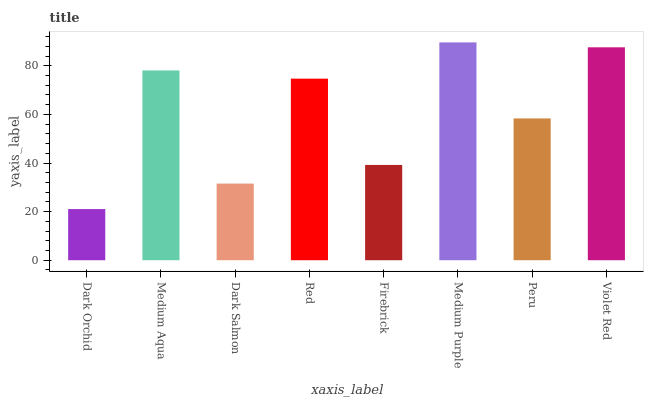Is Dark Orchid the minimum?
Answer yes or no. Yes. Is Medium Purple the maximum?
Answer yes or no. Yes. Is Medium Aqua the minimum?
Answer yes or no. No. Is Medium Aqua the maximum?
Answer yes or no. No. Is Medium Aqua greater than Dark Orchid?
Answer yes or no. Yes. Is Dark Orchid less than Medium Aqua?
Answer yes or no. Yes. Is Dark Orchid greater than Medium Aqua?
Answer yes or no. No. Is Medium Aqua less than Dark Orchid?
Answer yes or no. No. Is Red the high median?
Answer yes or no. Yes. Is Peru the low median?
Answer yes or no. Yes. Is Firebrick the high median?
Answer yes or no. No. Is Red the low median?
Answer yes or no. No. 